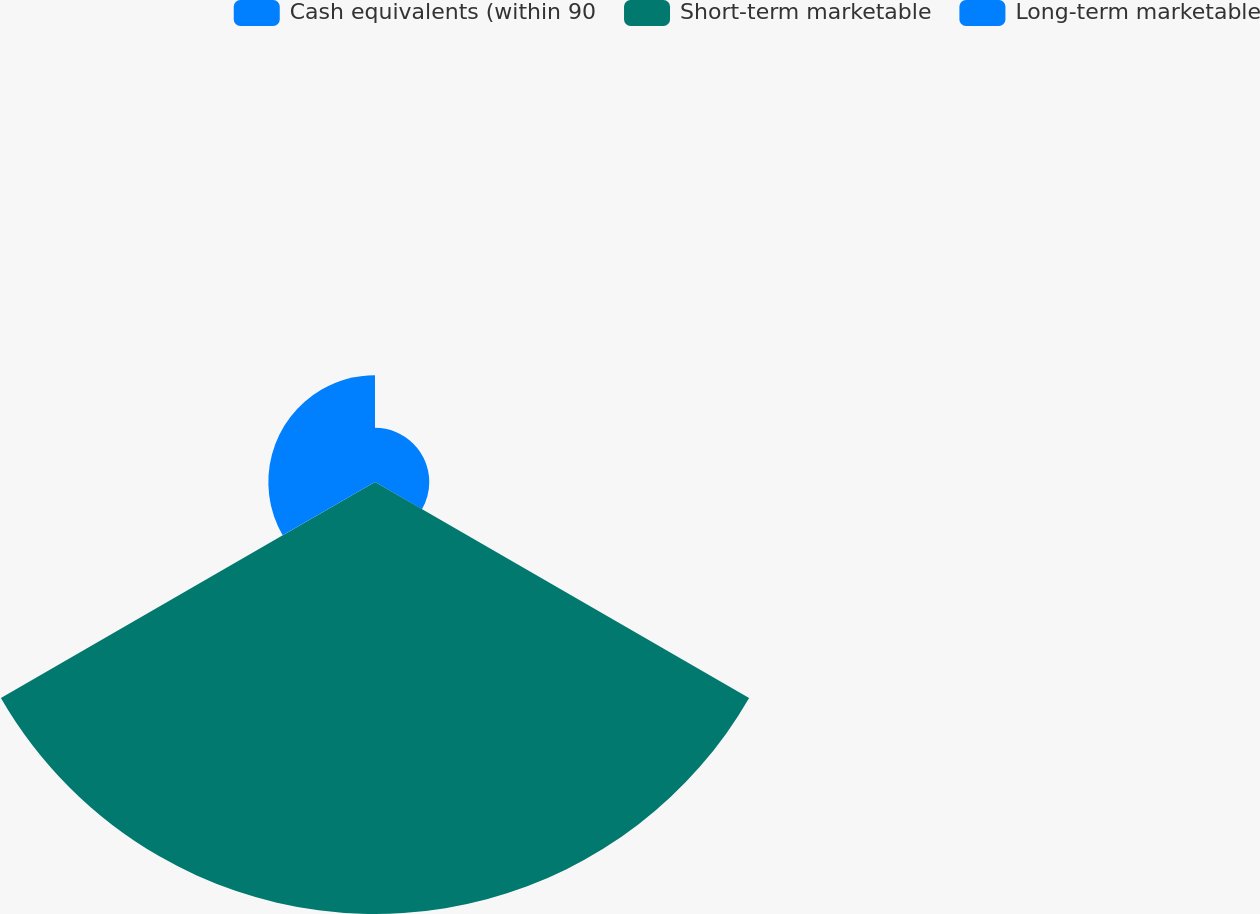<chart> <loc_0><loc_0><loc_500><loc_500><pie_chart><fcel>Cash equivalents (within 90<fcel>Short-term marketable<fcel>Long-term marketable<nl><fcel>9.15%<fcel>72.86%<fcel>17.99%<nl></chart> 